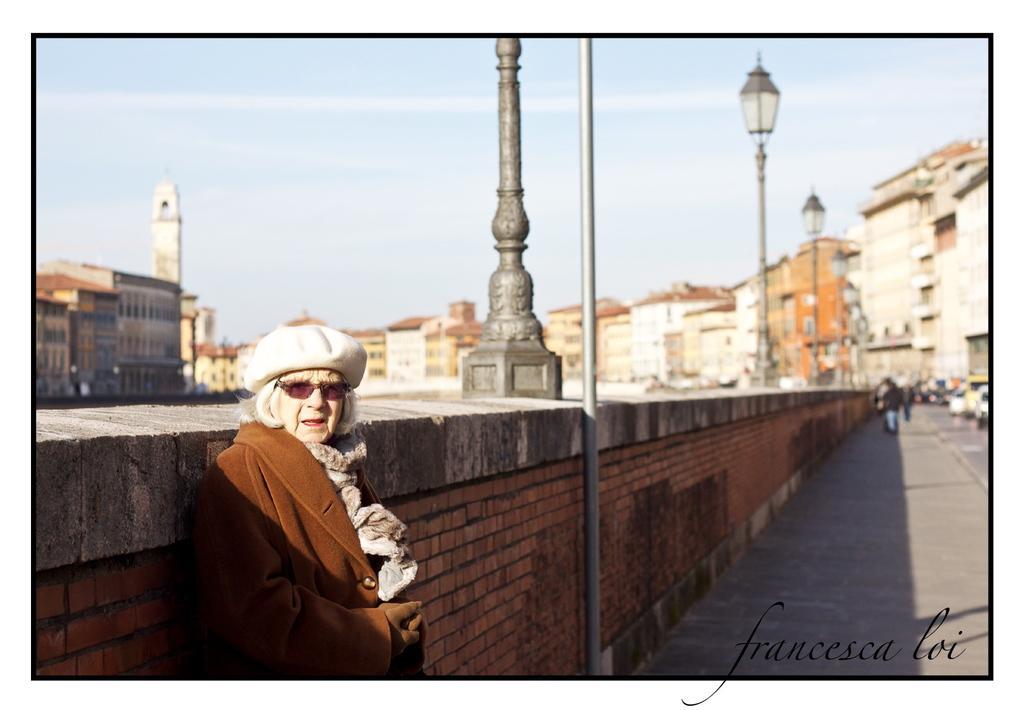In one or two sentences, can you explain what this image depicts? In this image we can see this old woman wearing glasses, hat and brown color coat is standing near the brick wall. The background of the image is blurred, where we can see light poles, people walking on the road, we can see buildings and the sky. Here we can see the watermark on the bottom right side of the image. 